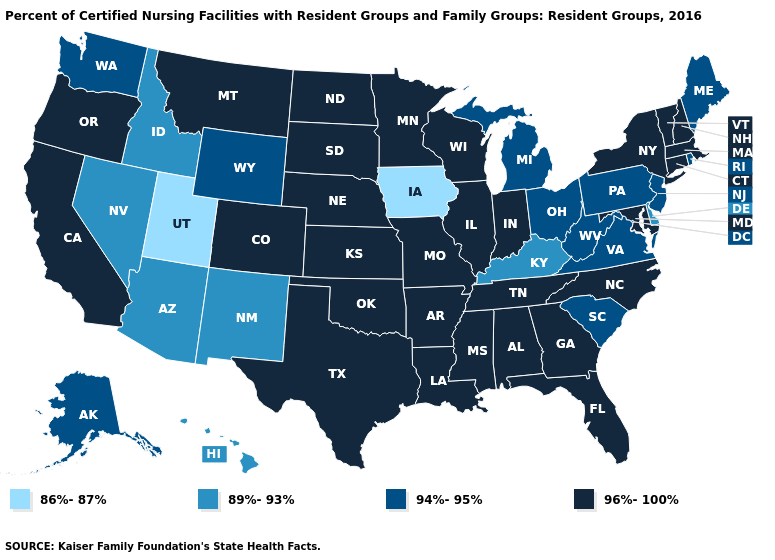What is the value of Vermont?
Write a very short answer. 96%-100%. Does the first symbol in the legend represent the smallest category?
Be succinct. Yes. What is the value of New Mexico?
Keep it brief. 89%-93%. Does North Dakota have a higher value than New York?
Be succinct. No. Among the states that border Arizona , does California have the lowest value?
Write a very short answer. No. Does Massachusetts have a higher value than New Hampshire?
Short answer required. No. What is the highest value in the USA?
Concise answer only. 96%-100%. What is the value of Rhode Island?
Be succinct. 94%-95%. Name the states that have a value in the range 96%-100%?
Write a very short answer. Alabama, Arkansas, California, Colorado, Connecticut, Florida, Georgia, Illinois, Indiana, Kansas, Louisiana, Maryland, Massachusetts, Minnesota, Mississippi, Missouri, Montana, Nebraska, New Hampshire, New York, North Carolina, North Dakota, Oklahoma, Oregon, South Dakota, Tennessee, Texas, Vermont, Wisconsin. Among the states that border Massachusetts , which have the lowest value?
Give a very brief answer. Rhode Island. What is the value of Kansas?
Short answer required. 96%-100%. Name the states that have a value in the range 94%-95%?
Short answer required. Alaska, Maine, Michigan, New Jersey, Ohio, Pennsylvania, Rhode Island, South Carolina, Virginia, Washington, West Virginia, Wyoming. Among the states that border New Hampshire , does Maine have the lowest value?
Short answer required. Yes. Name the states that have a value in the range 89%-93%?
Keep it brief. Arizona, Delaware, Hawaii, Idaho, Kentucky, Nevada, New Mexico. Among the states that border Utah , does Colorado have the highest value?
Answer briefly. Yes. 